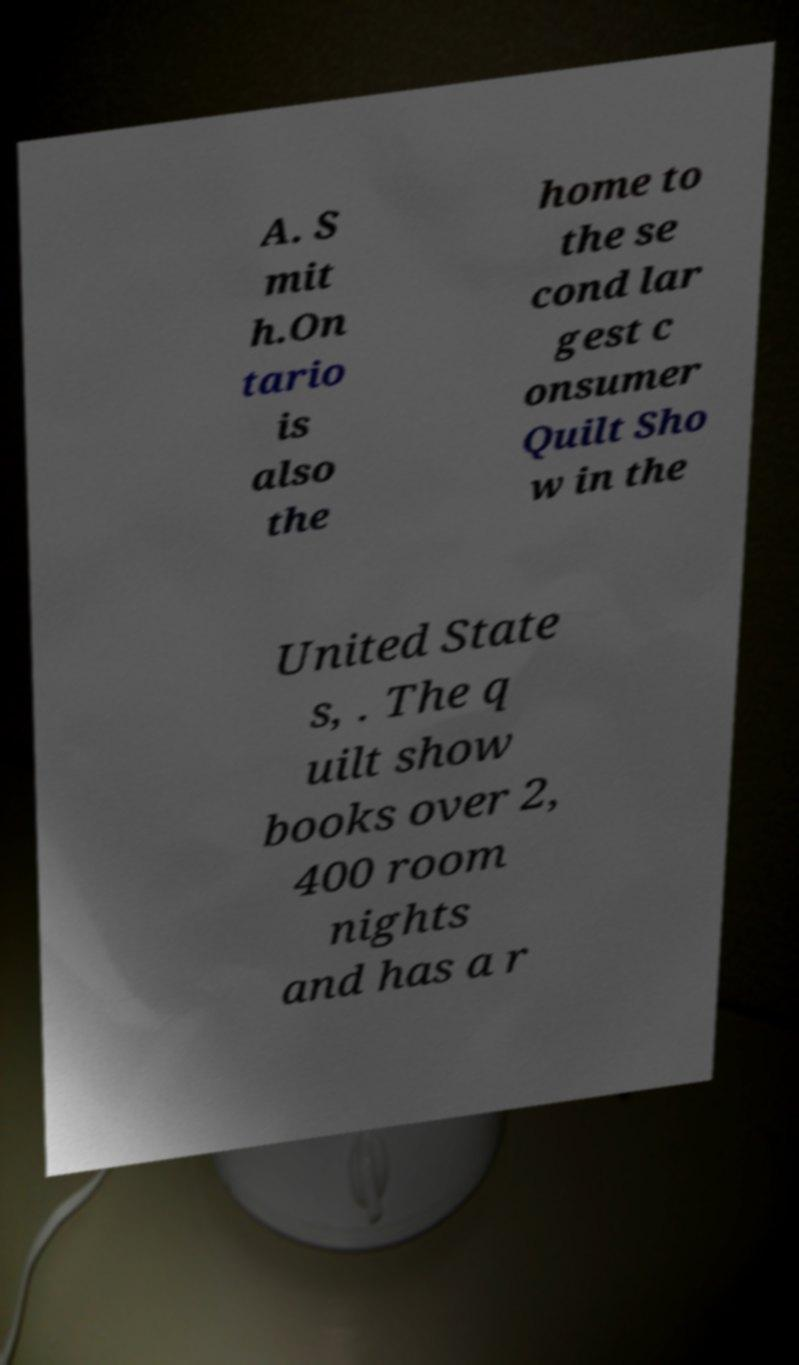Can you accurately transcribe the text from the provided image for me? A. S mit h.On tario is also the home to the se cond lar gest c onsumer Quilt Sho w in the United State s, . The q uilt show books over 2, 400 room nights and has a r 